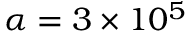Convert formula to latex. <formula><loc_0><loc_0><loc_500><loc_500>\alpha = 3 \times 1 0 ^ { 5 }</formula> 